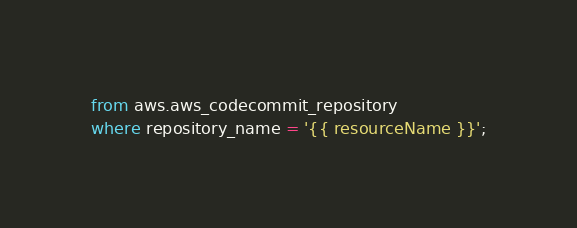<code> <loc_0><loc_0><loc_500><loc_500><_SQL_>from aws.aws_codecommit_repository
where repository_name = '{{ resourceName }}';</code> 